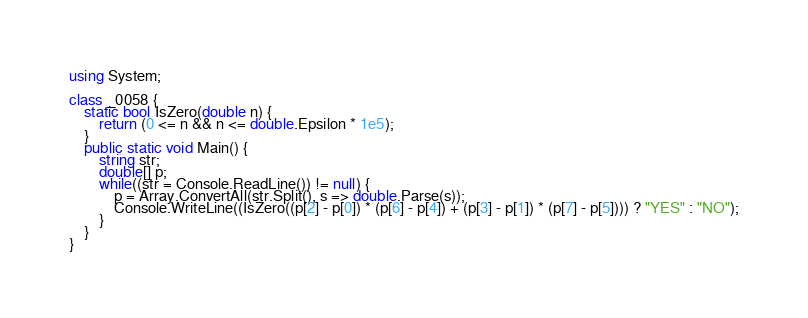Convert code to text. <code><loc_0><loc_0><loc_500><loc_500><_C#_>using System;

class _0058 {
    static bool IsZero(double n) {
        return (0 <= n && n <= double.Epsilon * 1e5);
    }
    public static void Main() {
        string str;
        double[] p;
        while((str = Console.ReadLine()) != null) {
            p = Array.ConvertAll(str.Split(), s => double.Parse(s));
            Console.WriteLine((IsZero((p[2] - p[0]) * (p[6] - p[4]) + (p[3] - p[1]) * (p[7] - p[5]))) ? "YES" : "NO");
        }
    }
}</code> 